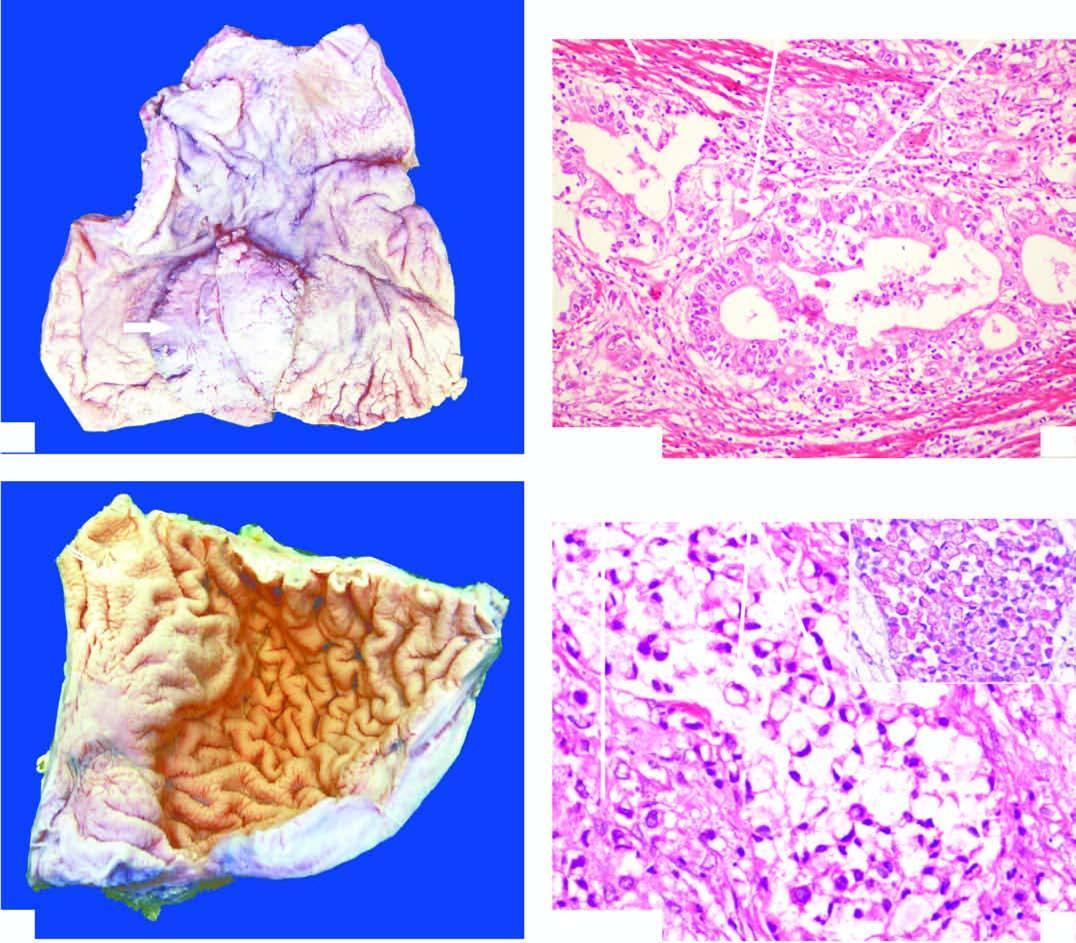s the wall of the stomach in the region of pyloric canal markedly thickened?
Answer the question using a single word or phrase. Yes 